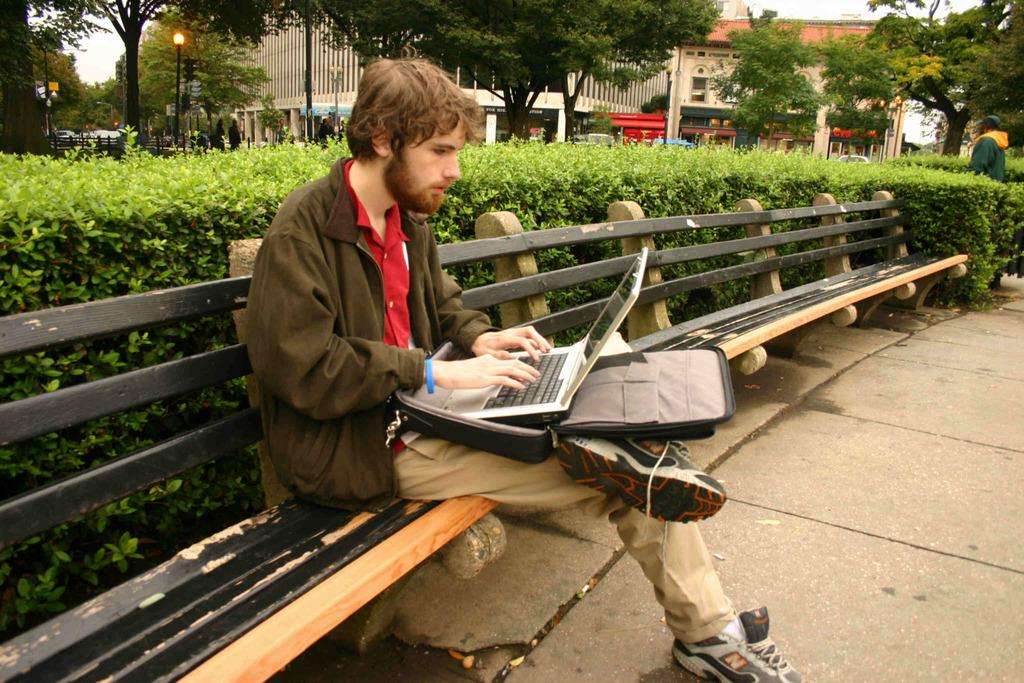What is the man in the image doing? The man is sitting on a bench in the image. What object does the man have on his lap? The man has a laptop on his lap. What can be seen in the background of the image? There are plants, trees, and a building in the background of the image. What degree does the person sitting at the table have in the image? There is no person sitting at a table in the image, nor is there any mention of a degree. 